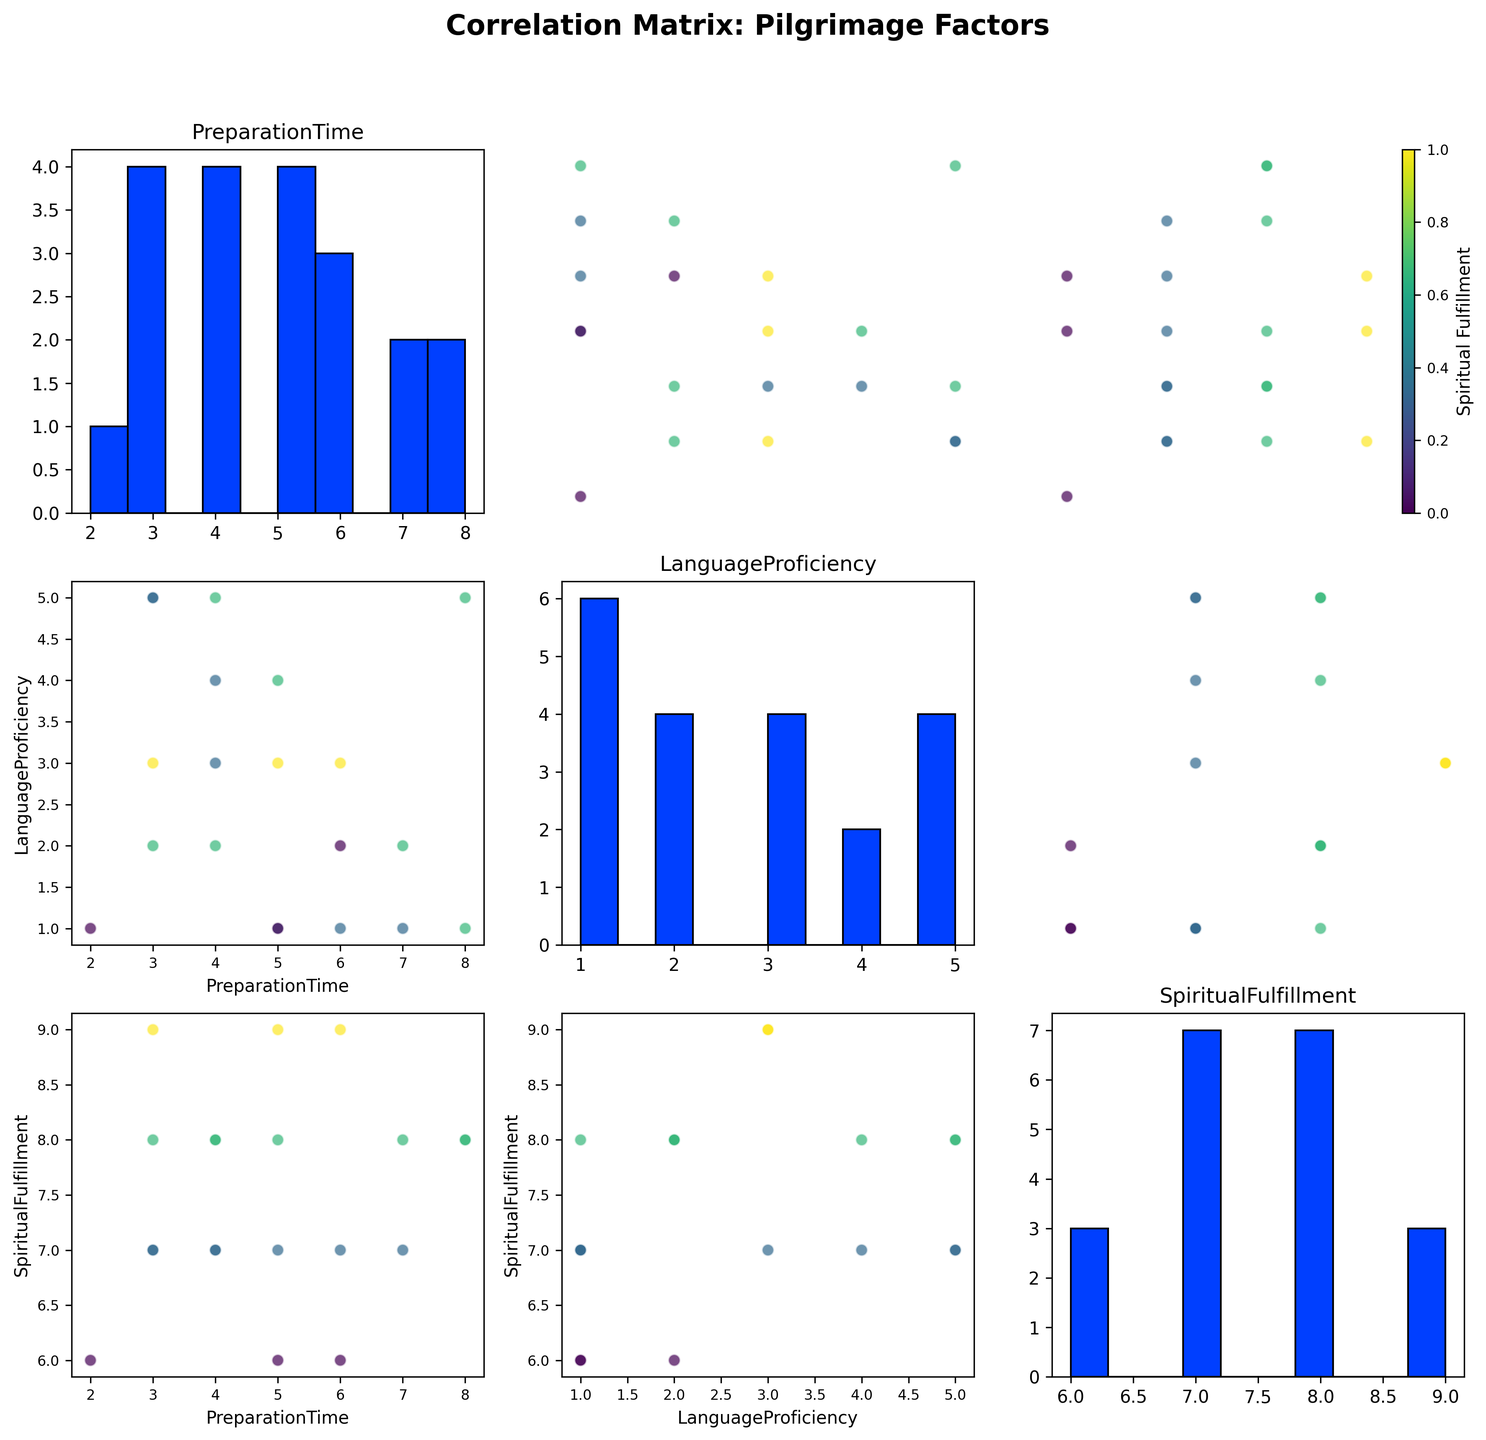What are the axis labels for the scatter plot in the first row and second column? The scatter plot in the first row and second column compares 'Language Proficiency' (x-axis) with 'Preparation Time' (y-axis). You can find these labels by looking at the respective axes.
Answer: x-axis: Language Proficiency, y-axis: Preparation Time How many data points are there in the dataset? To determine the number of data points, you can count the number of dots in any scatter plot within the matrix. Each scatter plot should have the same number of data points since it's the same dataset.
Answer: 19 What is the histogram title in the third row and third column? The histogram in the third row and third column corresponds to the 'Spiritual Fulfillment' variable. The title is the name of the variable this histogram represents.
Answer: Spiritual Fulfillment Which country has the highest preparation time and what is their spiritual fulfillment level? Looking at the scatter plot in the first row compared to 'Preparation Time', identify the data point with the maximum 'Preparation Time'. The UK and Australia both have the highest preparation time (8), and their respective spiritual fulfillment levels are 8.
Answer: United Kingdom / Australia, 8 each Is there a positive relationship between language proficiency and spiritual fulfillment in the data set? Look at the scatter plot where the x-axis is 'Language Proficiency' and the y-axis is 'Spiritual Fulfillment' (third row, second column). Check if there is a trend; however, it seems to lack a clear upward trend, suggesting no obvious positive relationship.
Answer: No clear positive relationship Which variable shows the highest variability in its histogram? Compare the spread of data in the histograms in terms of their distribution spread and number of bins used. 'Preparation Time' appears more spread out compared to 'Language Proficiency' and 'Spiritual Fulfillment'.
Answer: Preparation Time Which country scores equally high in both language proficiency and spiritual fulfillment? Find a data point where the 'Language Proficiency' and 'Spiritual Fulfillment' scores are both high and equal. Iran, Jordan, and Egypt have high scores (level 5) in both.
Answer: Iran/Jordan/Egypt Is there a data point that stands out significantly from others in terms of preparation time? Look for an outlier in the 'Preparation Time' scatter plot. This might be a point much higher or lower than the others. United Kingdom and Australia, both at the high end with a Preparation Time of 8, can be considered prominently different.
Answer: United Kingdom / Australia, Preparation Time = 8 